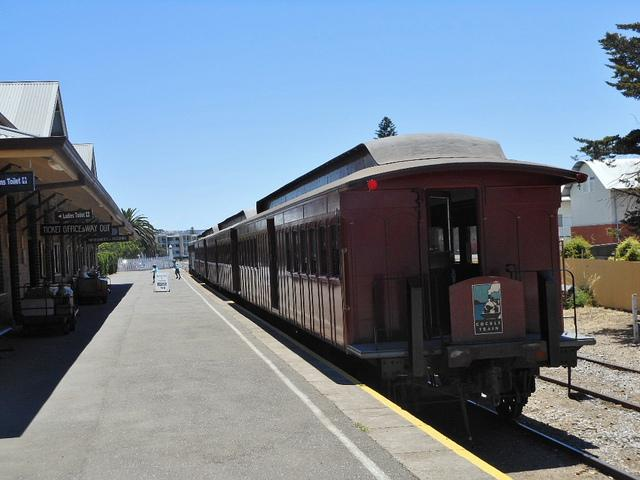What might the red light mean?

Choices:
A) ready
B) loading
C) unavailable
D) stop unavailable 